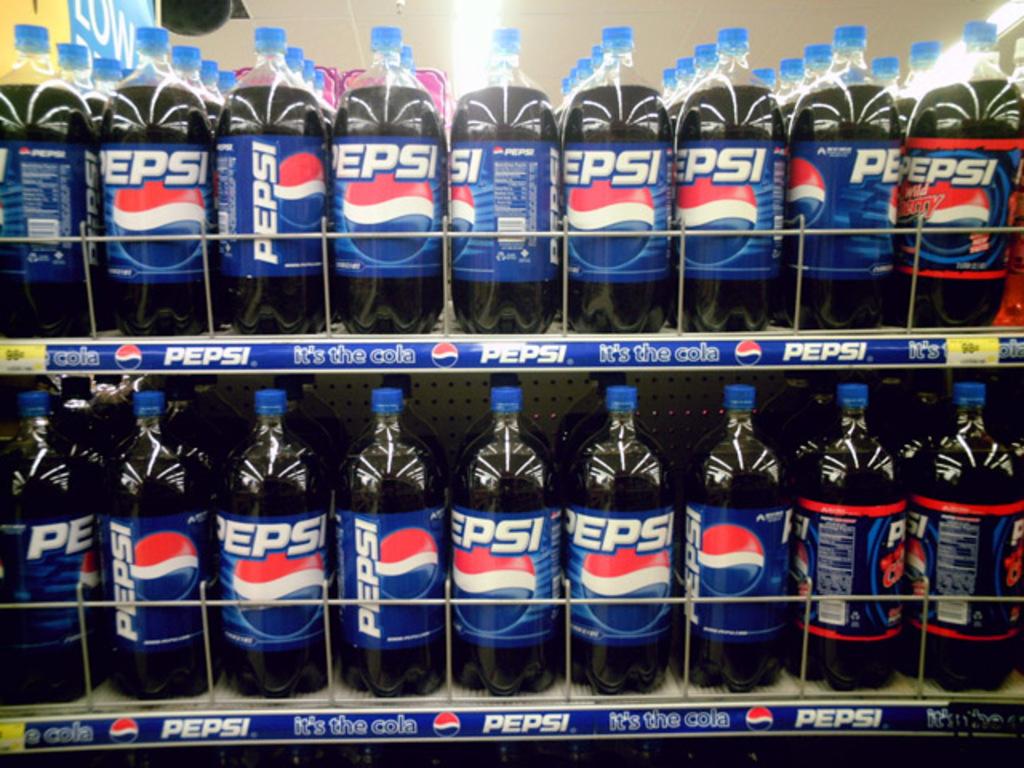What flavor of pepsi is on the right?
Provide a short and direct response. Wild cherry. 